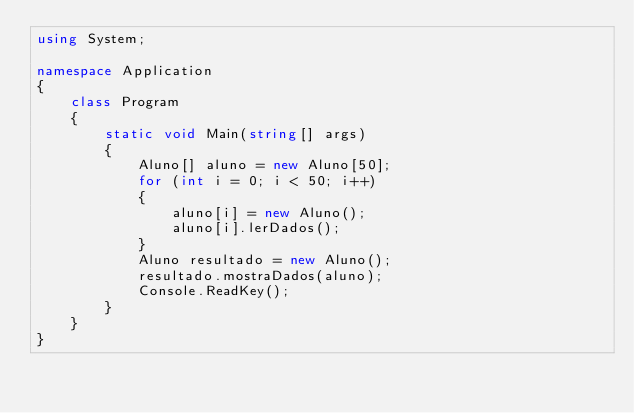Convert code to text. <code><loc_0><loc_0><loc_500><loc_500><_C#_>using System;

namespace Application
{
    class Program
    {
        static void Main(string[] args)
        {
            Aluno[] aluno = new Aluno[50];
            for (int i = 0; i < 50; i++)
            {
                aluno[i] = new Aluno();
                aluno[i].lerDados();
            }
            Aluno resultado = new Aluno();
            resultado.mostraDados(aluno);
            Console.ReadKey();
        }
    }
}</code> 